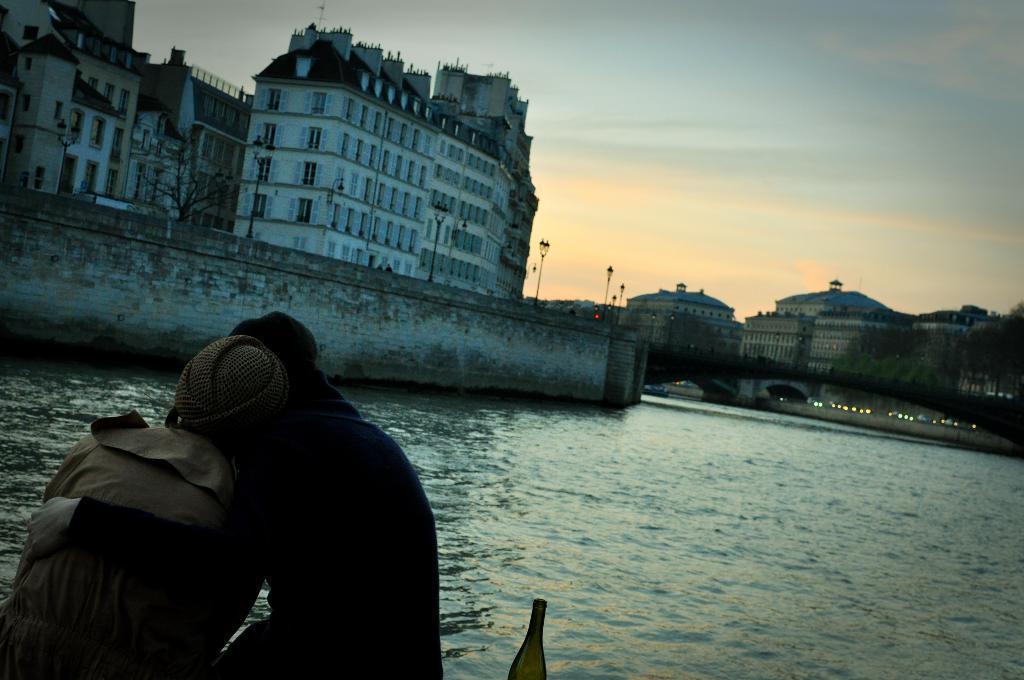Can you describe this image briefly? In this image I can see sitting to the side of the water. I can also see the bottle to the side of these people. In the background there is a wall and I can also see the light poles to the side. There are many buildings and trees. I can also see the sky in the back. 